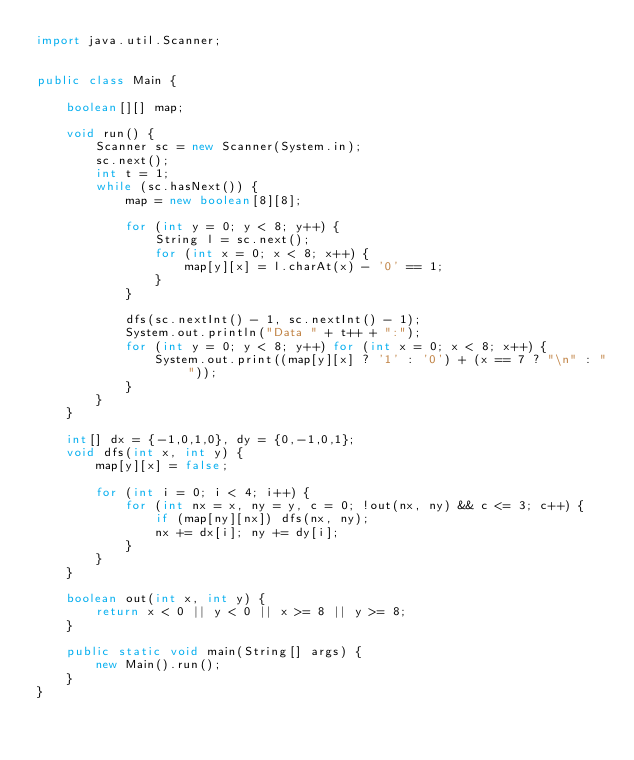Convert code to text. <code><loc_0><loc_0><loc_500><loc_500><_Java_>import java.util.Scanner;


public class Main {
    
    boolean[][] map;
    
    void run() {
        Scanner sc = new Scanner(System.in);
        sc.next();
        int t = 1;
        while (sc.hasNext()) {
            map = new boolean[8][8];
            
            for (int y = 0; y < 8; y++) {
                String l = sc.next();
                for (int x = 0; x < 8; x++) {
                    map[y][x] = l.charAt(x) - '0' == 1;
                }
            }
            
            dfs(sc.nextInt() - 1, sc.nextInt() - 1);
            System.out.println("Data " + t++ + ":");
            for (int y = 0; y < 8; y++) for (int x = 0; x < 8; x++) {
                System.out.print((map[y][x] ? '1' : '0') + (x == 7 ? "\n" : ""));
            }
        }
    }
    
    int[] dx = {-1,0,1,0}, dy = {0,-1,0,1};
    void dfs(int x, int y) {
        map[y][x] = false;
        
        for (int i = 0; i < 4; i++) {
            for (int nx = x, ny = y, c = 0; !out(nx, ny) && c <= 3; c++) {
                if (map[ny][nx]) dfs(nx, ny);
                nx += dx[i]; ny += dy[i];
            }
        }
    }
    
    boolean out(int x, int y) {
        return x < 0 || y < 0 || x >= 8 || y >= 8;
    }
    
    public static void main(String[] args) {
        new Main().run();
    }
}</code> 